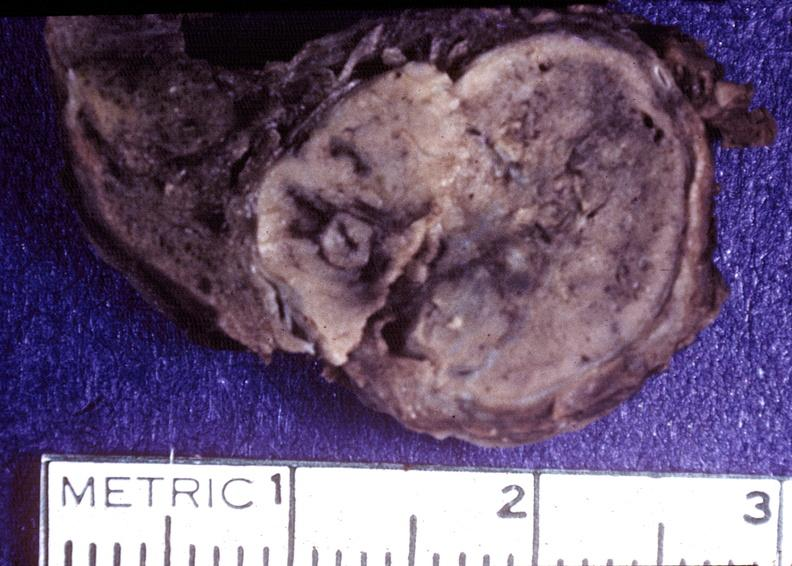s stillborn cord around neck present?
Answer the question using a single word or phrase. No 